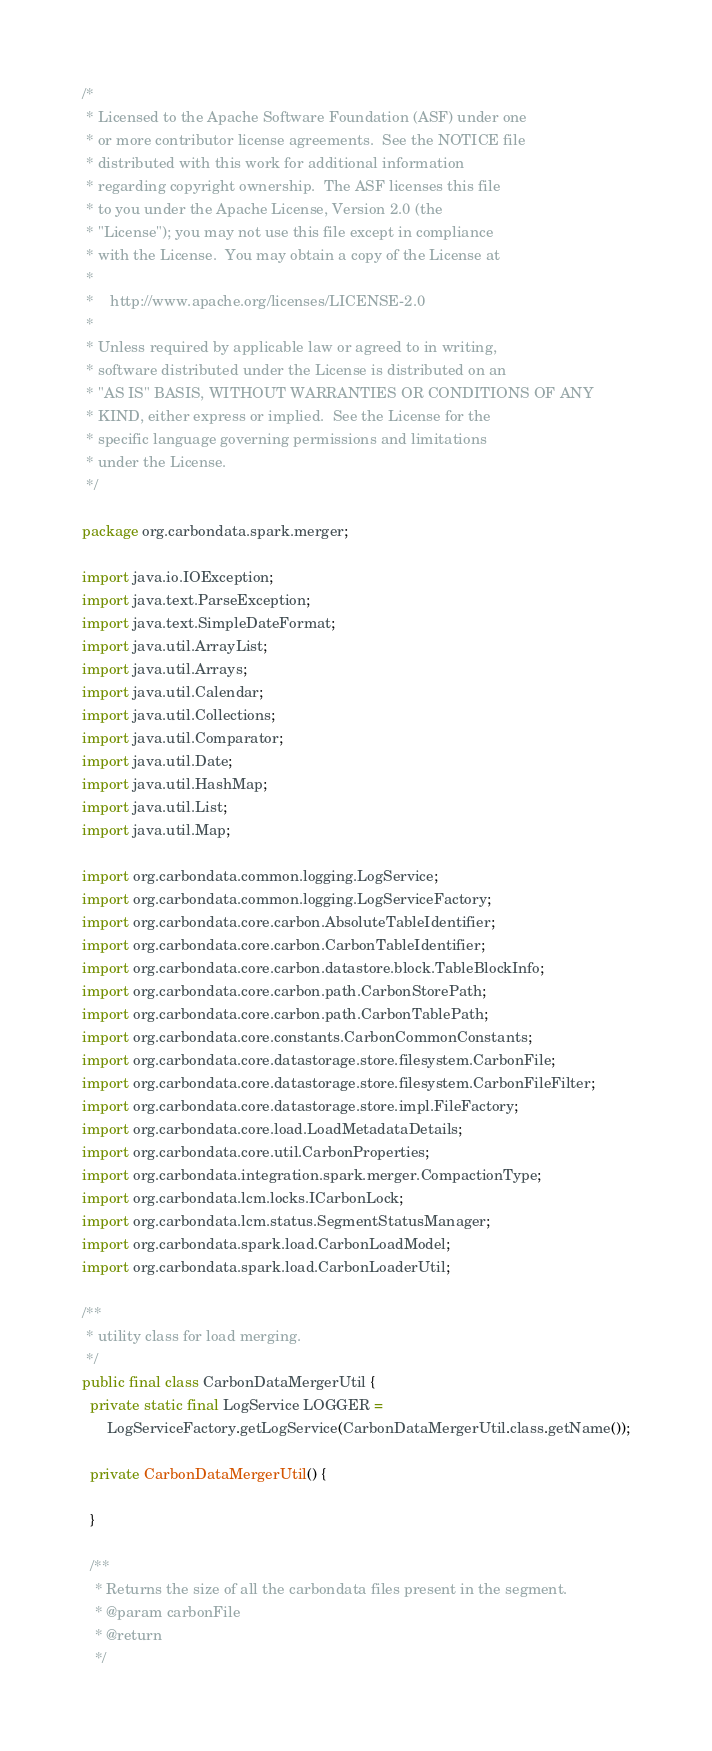<code> <loc_0><loc_0><loc_500><loc_500><_Java_>/*
 * Licensed to the Apache Software Foundation (ASF) under one
 * or more contributor license agreements.  See the NOTICE file
 * distributed with this work for additional information
 * regarding copyright ownership.  The ASF licenses this file
 * to you under the Apache License, Version 2.0 (the
 * "License"); you may not use this file except in compliance
 * with the License.  You may obtain a copy of the License at
 *
 *    http://www.apache.org/licenses/LICENSE-2.0
 *
 * Unless required by applicable law or agreed to in writing,
 * software distributed under the License is distributed on an
 * "AS IS" BASIS, WITHOUT WARRANTIES OR CONDITIONS OF ANY
 * KIND, either express or implied.  See the License for the
 * specific language governing permissions and limitations
 * under the License.
 */

package org.carbondata.spark.merger;

import java.io.IOException;
import java.text.ParseException;
import java.text.SimpleDateFormat;
import java.util.ArrayList;
import java.util.Arrays;
import java.util.Calendar;
import java.util.Collections;
import java.util.Comparator;
import java.util.Date;
import java.util.HashMap;
import java.util.List;
import java.util.Map;

import org.carbondata.common.logging.LogService;
import org.carbondata.common.logging.LogServiceFactory;
import org.carbondata.core.carbon.AbsoluteTableIdentifier;
import org.carbondata.core.carbon.CarbonTableIdentifier;
import org.carbondata.core.carbon.datastore.block.TableBlockInfo;
import org.carbondata.core.carbon.path.CarbonStorePath;
import org.carbondata.core.carbon.path.CarbonTablePath;
import org.carbondata.core.constants.CarbonCommonConstants;
import org.carbondata.core.datastorage.store.filesystem.CarbonFile;
import org.carbondata.core.datastorage.store.filesystem.CarbonFileFilter;
import org.carbondata.core.datastorage.store.impl.FileFactory;
import org.carbondata.core.load.LoadMetadataDetails;
import org.carbondata.core.util.CarbonProperties;
import org.carbondata.integration.spark.merger.CompactionType;
import org.carbondata.lcm.locks.ICarbonLock;
import org.carbondata.lcm.status.SegmentStatusManager;
import org.carbondata.spark.load.CarbonLoadModel;
import org.carbondata.spark.load.CarbonLoaderUtil;

/**
 * utility class for load merging.
 */
public final class CarbonDataMergerUtil {
  private static final LogService LOGGER =
      LogServiceFactory.getLogService(CarbonDataMergerUtil.class.getName());

  private CarbonDataMergerUtil() {

  }

  /**
   * Returns the size of all the carbondata files present in the segment.
   * @param carbonFile
   * @return
   */</code> 